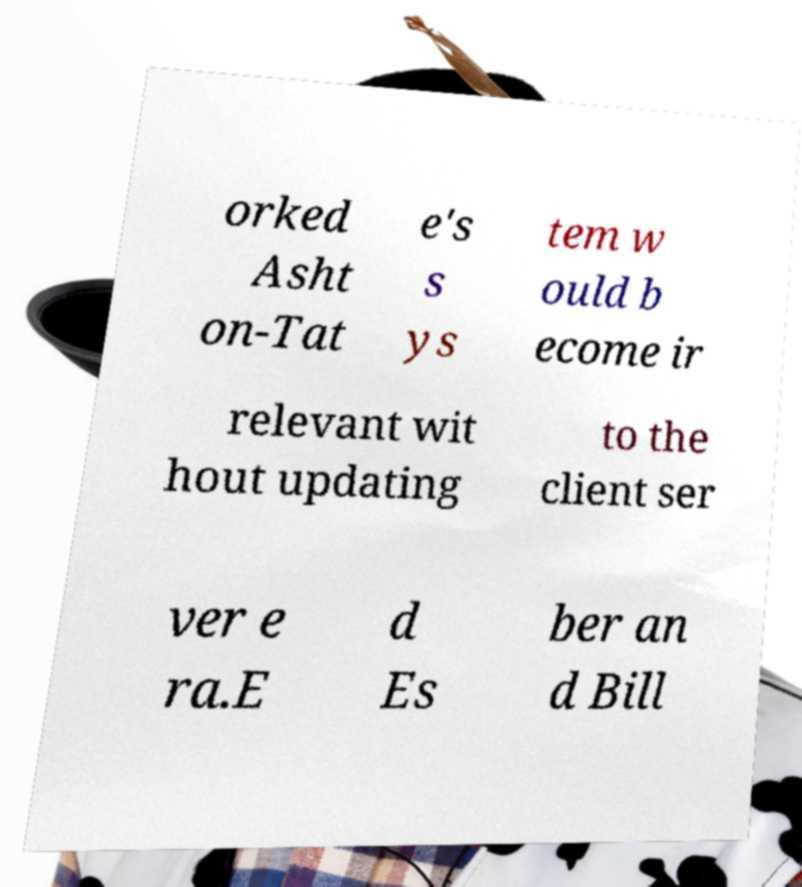Please read and relay the text visible in this image. What does it say? orked Asht on-Tat e's s ys tem w ould b ecome ir relevant wit hout updating to the client ser ver e ra.E d Es ber an d Bill 